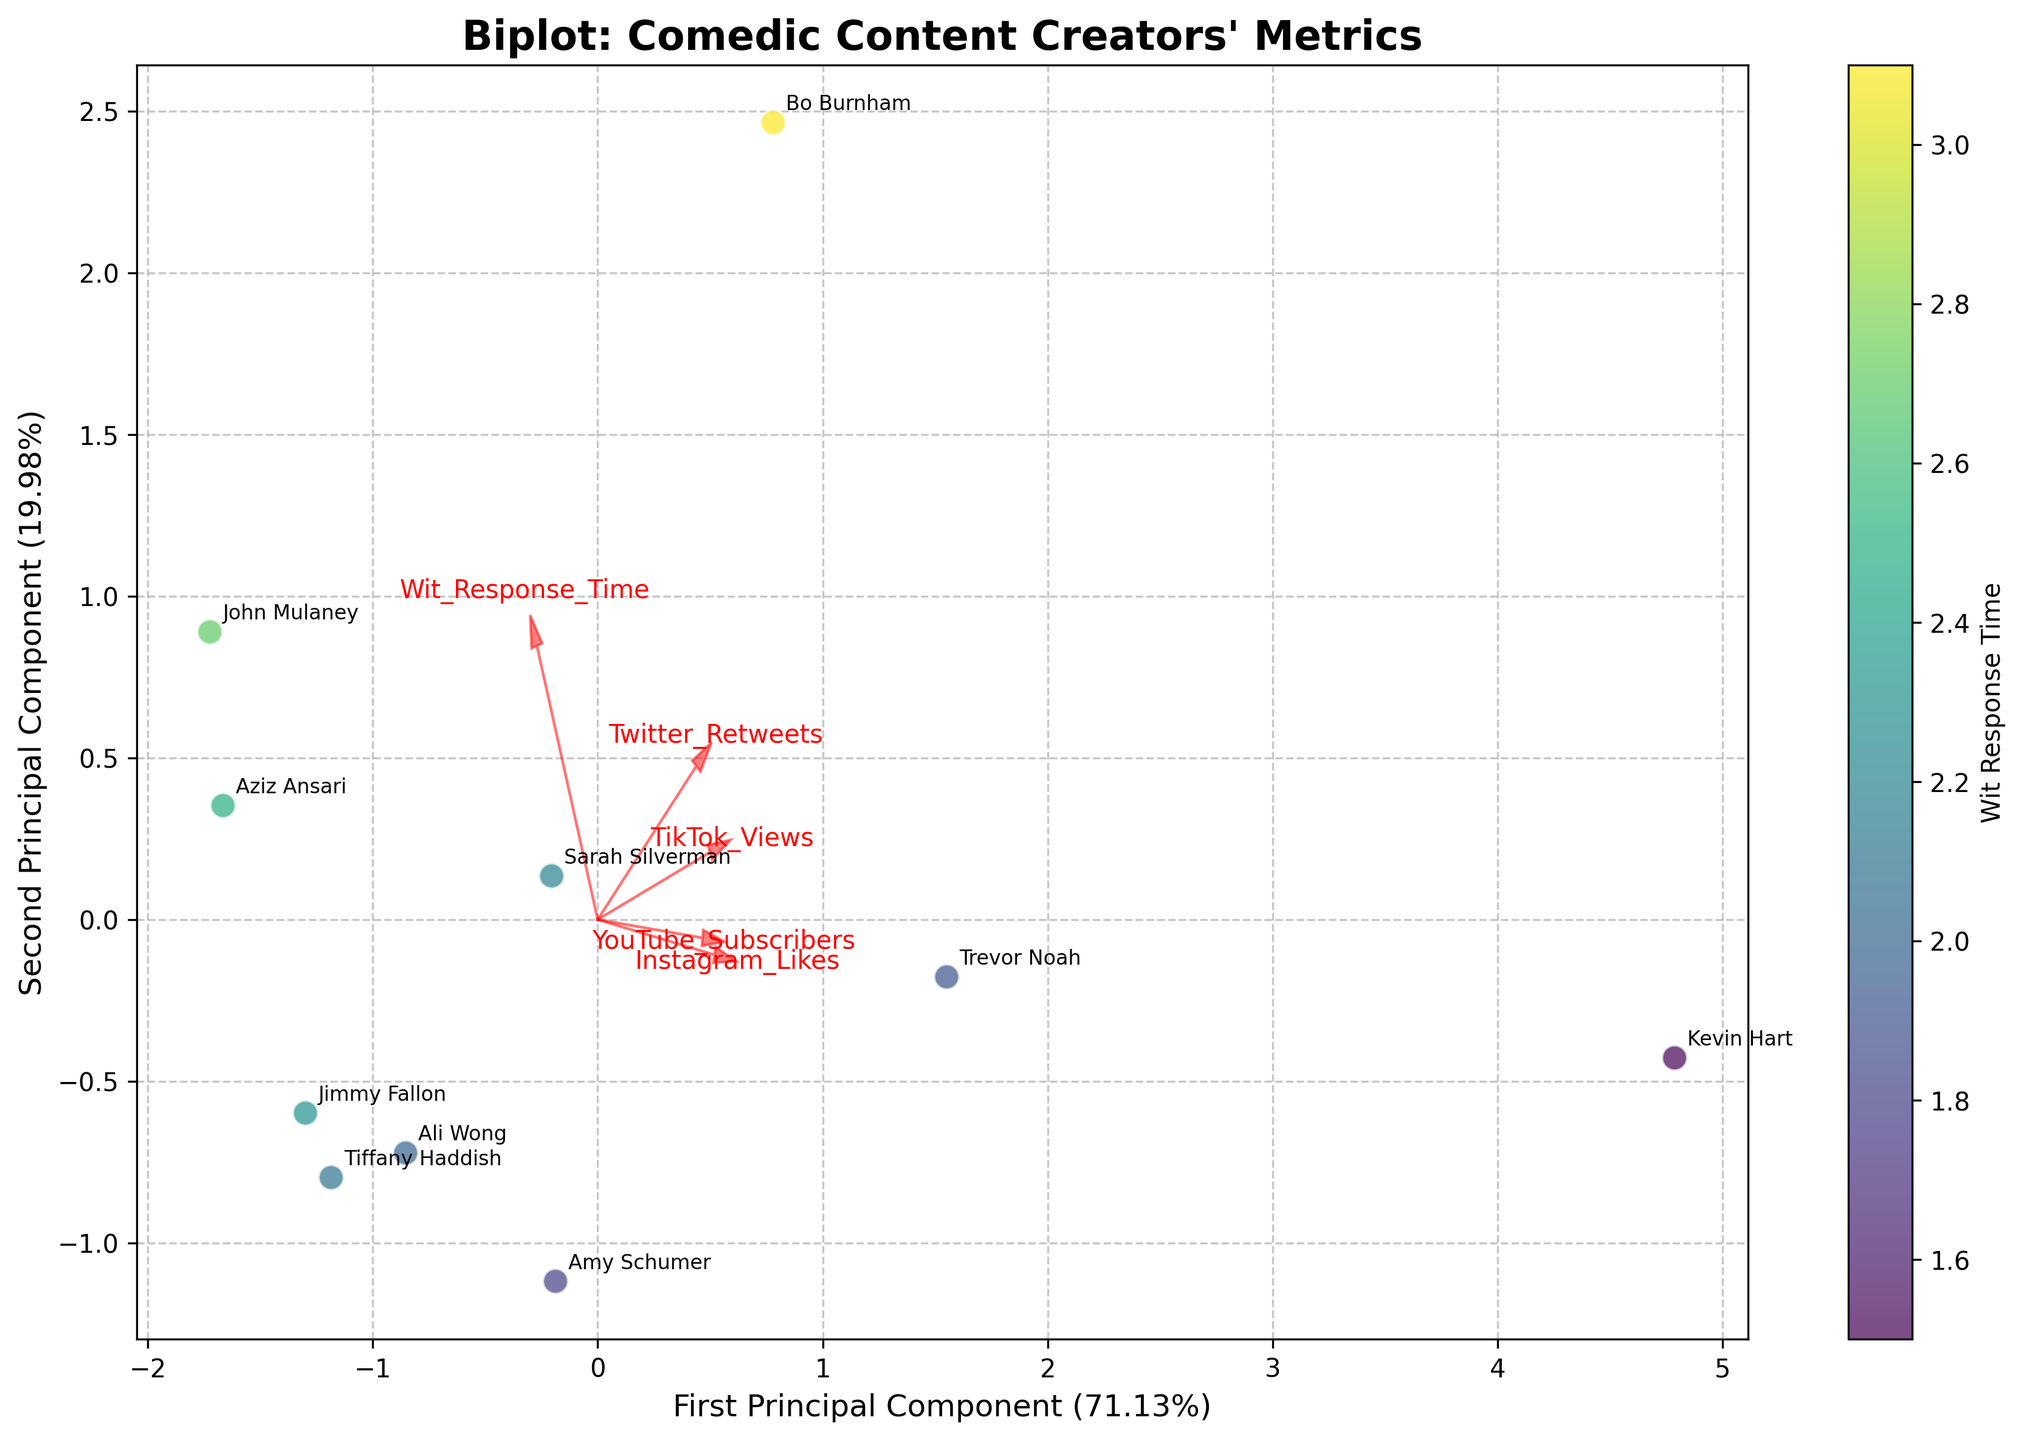Which comedian has the fastest wit response time? By examining the color gradient of the data points, the darkest color corresponds to the fastest wit response time. The label “Kevin Hart” is associated with the darkest color, indicating his wit response time is the fastest.
Answer: Kevin Hart What does the color gradient represent in the biplot? The color gradient on the scatter points represents the wit response time of each comedian, with different shades representing different response times.
Answer: Wit response time Which principal component explains more variance in the dataset? The axis labels in the biplot indicate the percentage of variance explained by each principal component. The first principal component explains a higher percentage of the variance.
Answer: First Principal Component Which two comedians have the most similar profile according to the biplot? By looking at the proximity of the data points and their positions on the biplot, Aziz Ansari and Tiffany Haddish are closely located, suggesting similar engagement profiles.
Answer: Aziz Ansari and Tiffany Haddish What's the relationship between Instagram likes and TikTok views, based on their arrows? The direction and angle between the arrows indicate the relationship. The arrows for Instagram likes and TikTok views point in similar directions, suggesting a positive correlation.
Answer: Positive correlation Which comedian appears to have the highest YouTube subscribers according to the biplot? The placement of data points and the direction of the YouTube subscribers vector indicate the comedian in the direction of the vector with a higher magnitude. "Kevin Hart" is aligned with a higher position along this vector.
Answer: Kevin Hart Are Twitter Retweets and Instagram Likes positively correlated? By examining the directions of the arrows for Twitter Retweets and Instagram Likes, they point in different directions, suggesting a weak or negative correlation.
Answer: Weak or Negative correlation What can you infer about Bo Burnham's social media engagement metrics? Bo Burnham is located far from the origin in the positive direction of both principal components, indicating higher metrics in the associated variables. This implies he performs well across several social media platforms.
Answer: High engagement metrics What does it suggest if a comedian's data point is far from the origin in the biplot? A data point far from the origin indicates that the comedian has extreme values (either very high or very low) in one or more engagement metrics based on the PCA.
Answer: Extreme values in engagement metrics Which metric seems to contribute the most to the first principal component? The length and direction of the arrows indicate each metric's contribution. The arrow for TikTok views has one of the longest projections along the first principal component axis.
Answer: TikTok views 